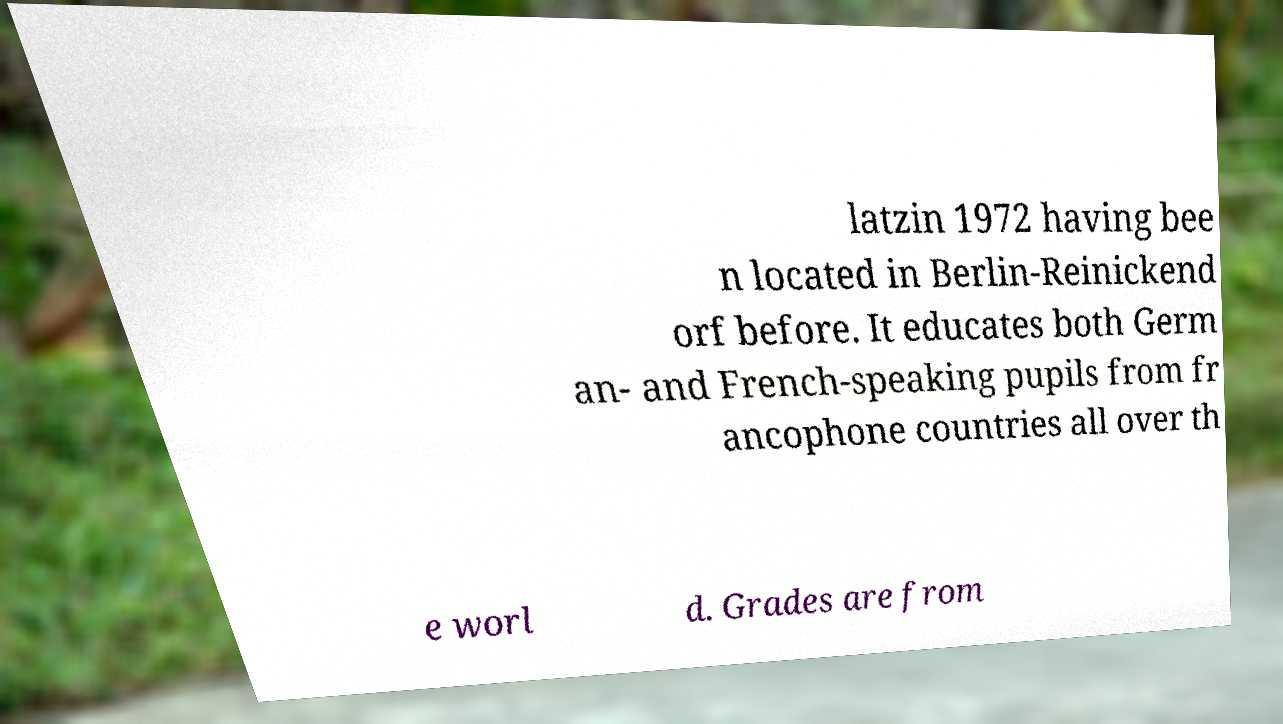Please identify and transcribe the text found in this image. latzin 1972 having bee n located in Berlin-Reinickend orf before. It educates both Germ an- and French-speaking pupils from fr ancophone countries all over th e worl d. Grades are from 